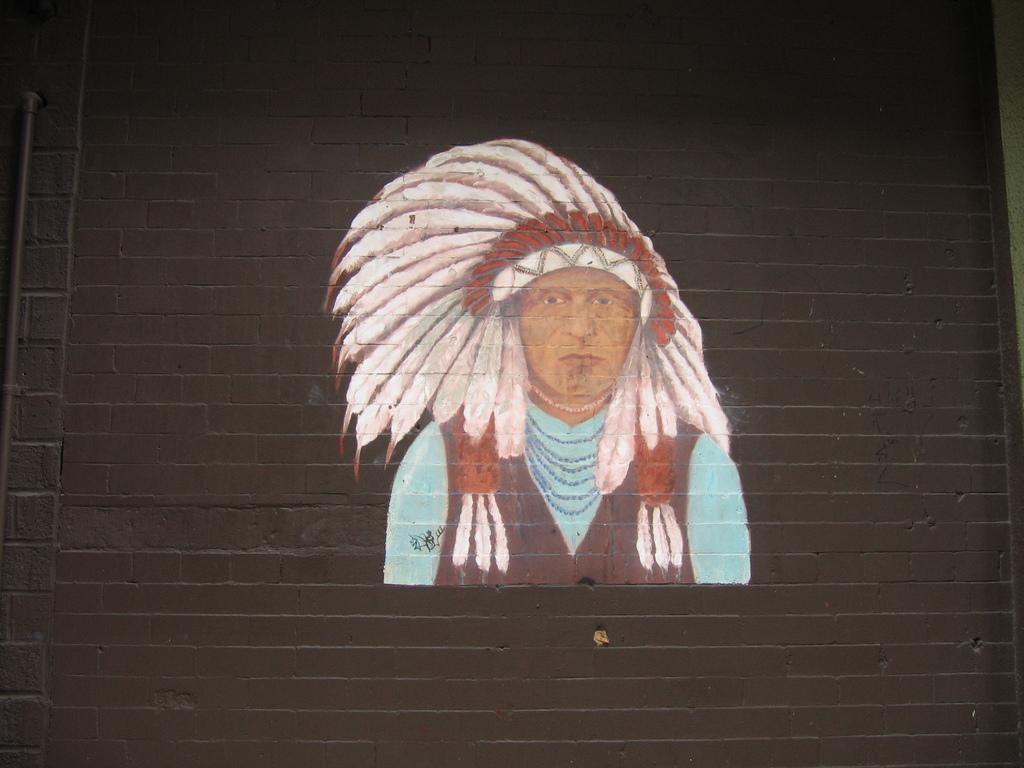Describe this image in one or two sentences. In this image we can see a wall on which a painting is done. 